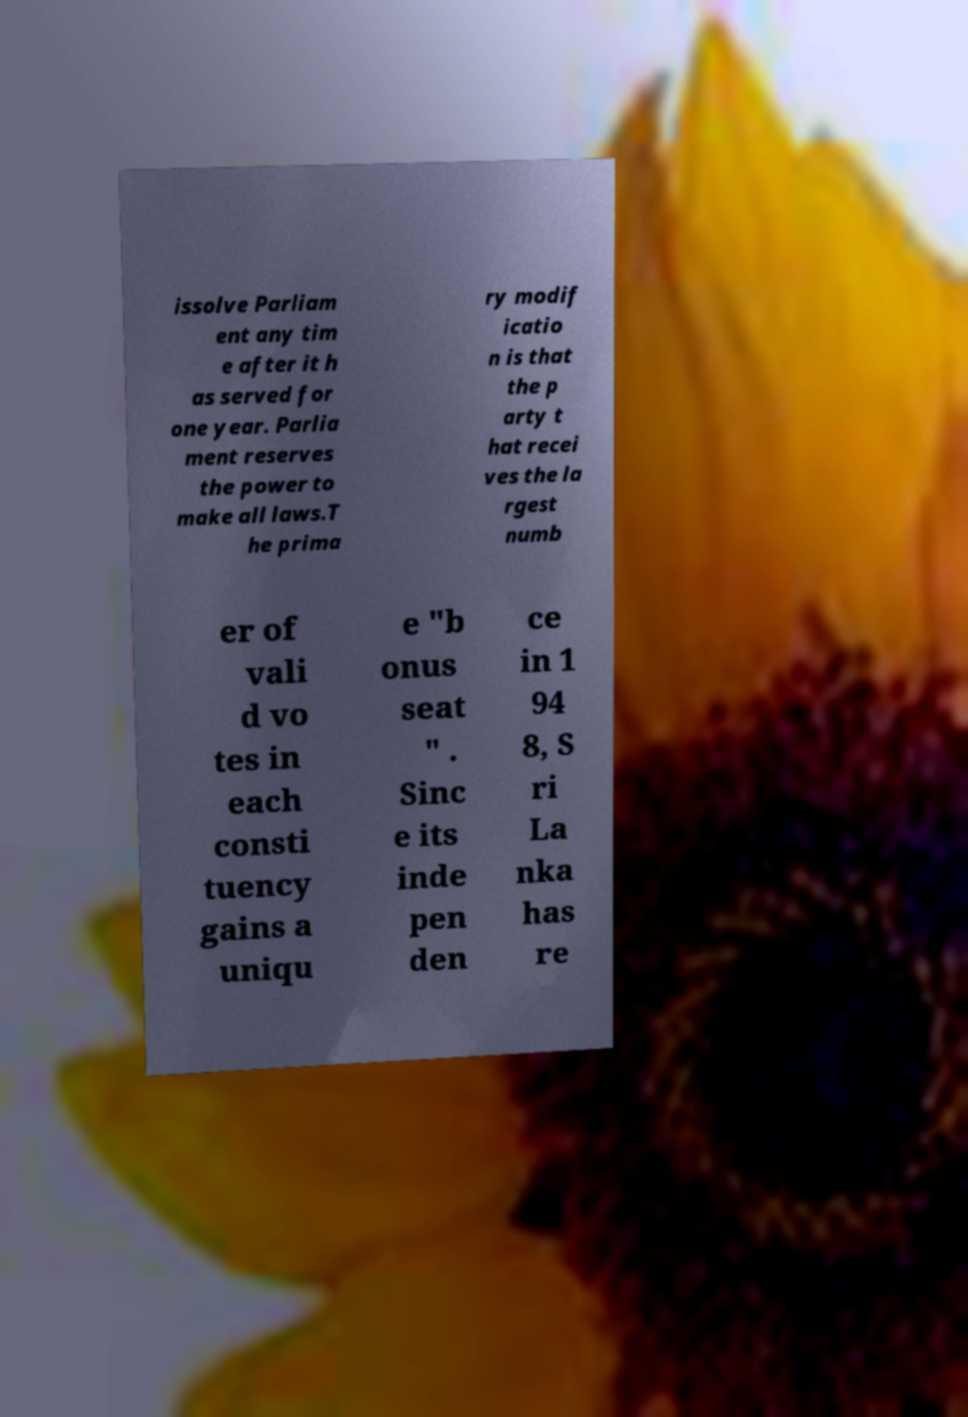What messages or text are displayed in this image? I need them in a readable, typed format. issolve Parliam ent any tim e after it h as served for one year. Parlia ment reserves the power to make all laws.T he prima ry modif icatio n is that the p arty t hat recei ves the la rgest numb er of vali d vo tes in each consti tuency gains a uniqu e "b onus seat " . Sinc e its inde pen den ce in 1 94 8, S ri La nka has re 